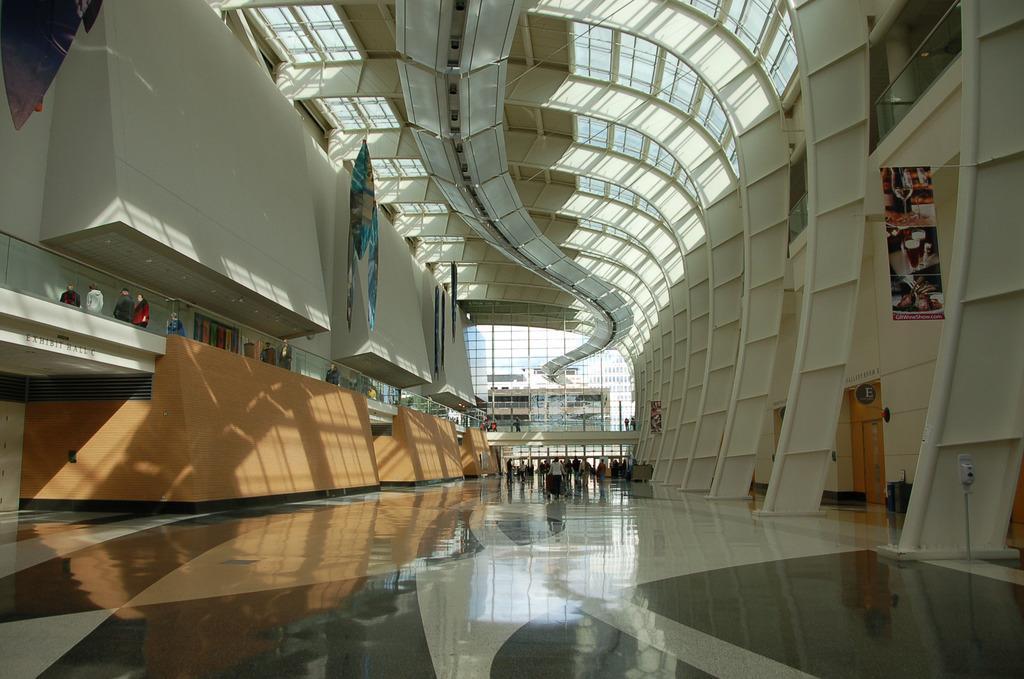In one or two sentences, can you explain what this image depicts? This is an inside view of a building. In this image, we can see walls, people, floor, banners, door, dustbins, board, glass objects, glass railings and few things. In the background, we can see glass objects and ceiling. 